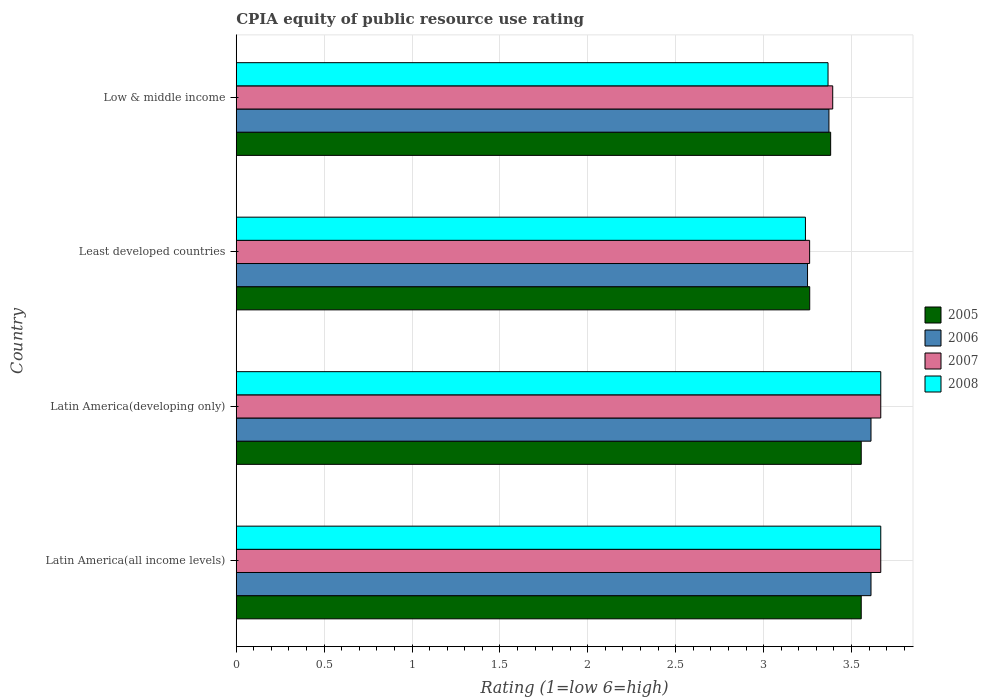How many different coloured bars are there?
Provide a short and direct response. 4. How many groups of bars are there?
Offer a very short reply. 4. Are the number of bars per tick equal to the number of legend labels?
Provide a short and direct response. Yes. How many bars are there on the 4th tick from the bottom?
Make the answer very short. 4. What is the label of the 4th group of bars from the top?
Your response must be concise. Latin America(all income levels). What is the CPIA rating in 2006 in Latin America(developing only)?
Your response must be concise. 3.61. Across all countries, what is the maximum CPIA rating in 2005?
Offer a terse response. 3.56. Across all countries, what is the minimum CPIA rating in 2008?
Your answer should be very brief. 3.24. In which country was the CPIA rating in 2005 maximum?
Make the answer very short. Latin America(all income levels). In which country was the CPIA rating in 2007 minimum?
Give a very brief answer. Least developed countries. What is the total CPIA rating in 2008 in the graph?
Make the answer very short. 13.94. What is the difference between the CPIA rating in 2008 in Latin America(developing only) and that in Least developed countries?
Provide a succinct answer. 0.43. What is the difference between the CPIA rating in 2007 in Latin America(all income levels) and the CPIA rating in 2005 in Least developed countries?
Your answer should be compact. 0.4. What is the average CPIA rating in 2007 per country?
Keep it short and to the point. 3.5. What is the difference between the CPIA rating in 2006 and CPIA rating in 2007 in Latin America(developing only)?
Your answer should be compact. -0.06. In how many countries, is the CPIA rating in 2006 greater than 3.4 ?
Your response must be concise. 2. What is the ratio of the CPIA rating in 2008 in Latin America(all income levels) to that in Low & middle income?
Provide a succinct answer. 1.09. Is the difference between the CPIA rating in 2006 in Latin America(developing only) and Low & middle income greater than the difference between the CPIA rating in 2007 in Latin America(developing only) and Low & middle income?
Make the answer very short. No. What is the difference between the highest and the lowest CPIA rating in 2006?
Ensure brevity in your answer.  0.36. In how many countries, is the CPIA rating in 2006 greater than the average CPIA rating in 2006 taken over all countries?
Make the answer very short. 2. Is it the case that in every country, the sum of the CPIA rating in 2005 and CPIA rating in 2008 is greater than the sum of CPIA rating in 2006 and CPIA rating in 2007?
Offer a very short reply. No. What does the 2nd bar from the top in Latin America(developing only) represents?
Offer a very short reply. 2007. What does the 4th bar from the bottom in Latin America(developing only) represents?
Your answer should be very brief. 2008. Is it the case that in every country, the sum of the CPIA rating in 2005 and CPIA rating in 2007 is greater than the CPIA rating in 2008?
Ensure brevity in your answer.  Yes. What is the difference between two consecutive major ticks on the X-axis?
Your answer should be compact. 0.5. Are the values on the major ticks of X-axis written in scientific E-notation?
Your answer should be very brief. No. Does the graph contain grids?
Ensure brevity in your answer.  Yes. How many legend labels are there?
Your response must be concise. 4. What is the title of the graph?
Your response must be concise. CPIA equity of public resource use rating. What is the label or title of the X-axis?
Make the answer very short. Rating (1=low 6=high). What is the label or title of the Y-axis?
Offer a terse response. Country. What is the Rating (1=low 6=high) of 2005 in Latin America(all income levels)?
Make the answer very short. 3.56. What is the Rating (1=low 6=high) in 2006 in Latin America(all income levels)?
Your response must be concise. 3.61. What is the Rating (1=low 6=high) in 2007 in Latin America(all income levels)?
Provide a succinct answer. 3.67. What is the Rating (1=low 6=high) of 2008 in Latin America(all income levels)?
Your answer should be compact. 3.67. What is the Rating (1=low 6=high) in 2005 in Latin America(developing only)?
Give a very brief answer. 3.56. What is the Rating (1=low 6=high) in 2006 in Latin America(developing only)?
Provide a short and direct response. 3.61. What is the Rating (1=low 6=high) of 2007 in Latin America(developing only)?
Your answer should be compact. 3.67. What is the Rating (1=low 6=high) of 2008 in Latin America(developing only)?
Ensure brevity in your answer.  3.67. What is the Rating (1=low 6=high) in 2005 in Least developed countries?
Offer a very short reply. 3.26. What is the Rating (1=low 6=high) of 2006 in Least developed countries?
Give a very brief answer. 3.25. What is the Rating (1=low 6=high) in 2007 in Least developed countries?
Keep it short and to the point. 3.26. What is the Rating (1=low 6=high) in 2008 in Least developed countries?
Keep it short and to the point. 3.24. What is the Rating (1=low 6=high) of 2005 in Low & middle income?
Your response must be concise. 3.38. What is the Rating (1=low 6=high) of 2006 in Low & middle income?
Provide a succinct answer. 3.37. What is the Rating (1=low 6=high) of 2007 in Low & middle income?
Provide a succinct answer. 3.39. What is the Rating (1=low 6=high) of 2008 in Low & middle income?
Provide a succinct answer. 3.37. Across all countries, what is the maximum Rating (1=low 6=high) in 2005?
Your response must be concise. 3.56. Across all countries, what is the maximum Rating (1=low 6=high) in 2006?
Provide a short and direct response. 3.61. Across all countries, what is the maximum Rating (1=low 6=high) in 2007?
Your answer should be very brief. 3.67. Across all countries, what is the maximum Rating (1=low 6=high) of 2008?
Offer a very short reply. 3.67. Across all countries, what is the minimum Rating (1=low 6=high) in 2005?
Your answer should be compact. 3.26. Across all countries, what is the minimum Rating (1=low 6=high) of 2007?
Ensure brevity in your answer.  3.26. Across all countries, what is the minimum Rating (1=low 6=high) in 2008?
Ensure brevity in your answer.  3.24. What is the total Rating (1=low 6=high) of 2005 in the graph?
Provide a succinct answer. 13.76. What is the total Rating (1=low 6=high) of 2006 in the graph?
Your response must be concise. 13.84. What is the total Rating (1=low 6=high) in 2007 in the graph?
Make the answer very short. 13.99. What is the total Rating (1=low 6=high) of 2008 in the graph?
Offer a terse response. 13.94. What is the difference between the Rating (1=low 6=high) of 2005 in Latin America(all income levels) and that in Latin America(developing only)?
Your answer should be very brief. 0. What is the difference between the Rating (1=low 6=high) of 2006 in Latin America(all income levels) and that in Latin America(developing only)?
Provide a succinct answer. 0. What is the difference between the Rating (1=low 6=high) in 2008 in Latin America(all income levels) and that in Latin America(developing only)?
Offer a terse response. 0. What is the difference between the Rating (1=low 6=high) of 2005 in Latin America(all income levels) and that in Least developed countries?
Make the answer very short. 0.29. What is the difference between the Rating (1=low 6=high) in 2006 in Latin America(all income levels) and that in Least developed countries?
Ensure brevity in your answer.  0.36. What is the difference between the Rating (1=low 6=high) of 2007 in Latin America(all income levels) and that in Least developed countries?
Your response must be concise. 0.4. What is the difference between the Rating (1=low 6=high) of 2008 in Latin America(all income levels) and that in Least developed countries?
Ensure brevity in your answer.  0.43. What is the difference between the Rating (1=low 6=high) in 2005 in Latin America(all income levels) and that in Low & middle income?
Your answer should be compact. 0.17. What is the difference between the Rating (1=low 6=high) of 2006 in Latin America(all income levels) and that in Low & middle income?
Offer a very short reply. 0.24. What is the difference between the Rating (1=low 6=high) in 2007 in Latin America(all income levels) and that in Low & middle income?
Your answer should be compact. 0.27. What is the difference between the Rating (1=low 6=high) of 2008 in Latin America(all income levels) and that in Low & middle income?
Provide a short and direct response. 0.3. What is the difference between the Rating (1=low 6=high) of 2005 in Latin America(developing only) and that in Least developed countries?
Your response must be concise. 0.29. What is the difference between the Rating (1=low 6=high) in 2006 in Latin America(developing only) and that in Least developed countries?
Provide a succinct answer. 0.36. What is the difference between the Rating (1=low 6=high) of 2007 in Latin America(developing only) and that in Least developed countries?
Your answer should be very brief. 0.4. What is the difference between the Rating (1=low 6=high) of 2008 in Latin America(developing only) and that in Least developed countries?
Provide a succinct answer. 0.43. What is the difference between the Rating (1=low 6=high) in 2005 in Latin America(developing only) and that in Low & middle income?
Ensure brevity in your answer.  0.17. What is the difference between the Rating (1=low 6=high) in 2006 in Latin America(developing only) and that in Low & middle income?
Keep it short and to the point. 0.24. What is the difference between the Rating (1=low 6=high) of 2007 in Latin America(developing only) and that in Low & middle income?
Offer a terse response. 0.27. What is the difference between the Rating (1=low 6=high) in 2008 in Latin America(developing only) and that in Low & middle income?
Provide a succinct answer. 0.3. What is the difference between the Rating (1=low 6=high) of 2005 in Least developed countries and that in Low & middle income?
Your answer should be very brief. -0.12. What is the difference between the Rating (1=low 6=high) in 2006 in Least developed countries and that in Low & middle income?
Offer a very short reply. -0.12. What is the difference between the Rating (1=low 6=high) in 2007 in Least developed countries and that in Low & middle income?
Give a very brief answer. -0.13. What is the difference between the Rating (1=low 6=high) of 2008 in Least developed countries and that in Low & middle income?
Keep it short and to the point. -0.13. What is the difference between the Rating (1=low 6=high) in 2005 in Latin America(all income levels) and the Rating (1=low 6=high) in 2006 in Latin America(developing only)?
Keep it short and to the point. -0.06. What is the difference between the Rating (1=low 6=high) of 2005 in Latin America(all income levels) and the Rating (1=low 6=high) of 2007 in Latin America(developing only)?
Offer a terse response. -0.11. What is the difference between the Rating (1=low 6=high) of 2005 in Latin America(all income levels) and the Rating (1=low 6=high) of 2008 in Latin America(developing only)?
Your answer should be very brief. -0.11. What is the difference between the Rating (1=low 6=high) of 2006 in Latin America(all income levels) and the Rating (1=low 6=high) of 2007 in Latin America(developing only)?
Offer a terse response. -0.06. What is the difference between the Rating (1=low 6=high) of 2006 in Latin America(all income levels) and the Rating (1=low 6=high) of 2008 in Latin America(developing only)?
Your answer should be compact. -0.06. What is the difference between the Rating (1=low 6=high) of 2007 in Latin America(all income levels) and the Rating (1=low 6=high) of 2008 in Latin America(developing only)?
Provide a short and direct response. 0. What is the difference between the Rating (1=low 6=high) of 2005 in Latin America(all income levels) and the Rating (1=low 6=high) of 2006 in Least developed countries?
Your answer should be very brief. 0.31. What is the difference between the Rating (1=low 6=high) of 2005 in Latin America(all income levels) and the Rating (1=low 6=high) of 2007 in Least developed countries?
Offer a very short reply. 0.29. What is the difference between the Rating (1=low 6=high) in 2005 in Latin America(all income levels) and the Rating (1=low 6=high) in 2008 in Least developed countries?
Keep it short and to the point. 0.32. What is the difference between the Rating (1=low 6=high) in 2006 in Latin America(all income levels) and the Rating (1=low 6=high) in 2007 in Least developed countries?
Provide a succinct answer. 0.35. What is the difference between the Rating (1=low 6=high) of 2006 in Latin America(all income levels) and the Rating (1=low 6=high) of 2008 in Least developed countries?
Your answer should be very brief. 0.37. What is the difference between the Rating (1=low 6=high) in 2007 in Latin America(all income levels) and the Rating (1=low 6=high) in 2008 in Least developed countries?
Ensure brevity in your answer.  0.43. What is the difference between the Rating (1=low 6=high) of 2005 in Latin America(all income levels) and the Rating (1=low 6=high) of 2006 in Low & middle income?
Provide a succinct answer. 0.18. What is the difference between the Rating (1=low 6=high) of 2005 in Latin America(all income levels) and the Rating (1=low 6=high) of 2007 in Low & middle income?
Offer a very short reply. 0.16. What is the difference between the Rating (1=low 6=high) of 2005 in Latin America(all income levels) and the Rating (1=low 6=high) of 2008 in Low & middle income?
Keep it short and to the point. 0.19. What is the difference between the Rating (1=low 6=high) of 2006 in Latin America(all income levels) and the Rating (1=low 6=high) of 2007 in Low & middle income?
Ensure brevity in your answer.  0.22. What is the difference between the Rating (1=low 6=high) of 2006 in Latin America(all income levels) and the Rating (1=low 6=high) of 2008 in Low & middle income?
Offer a terse response. 0.24. What is the difference between the Rating (1=low 6=high) in 2005 in Latin America(developing only) and the Rating (1=low 6=high) in 2006 in Least developed countries?
Keep it short and to the point. 0.31. What is the difference between the Rating (1=low 6=high) of 2005 in Latin America(developing only) and the Rating (1=low 6=high) of 2007 in Least developed countries?
Your answer should be very brief. 0.29. What is the difference between the Rating (1=low 6=high) of 2005 in Latin America(developing only) and the Rating (1=low 6=high) of 2008 in Least developed countries?
Make the answer very short. 0.32. What is the difference between the Rating (1=low 6=high) of 2006 in Latin America(developing only) and the Rating (1=low 6=high) of 2007 in Least developed countries?
Offer a very short reply. 0.35. What is the difference between the Rating (1=low 6=high) in 2006 in Latin America(developing only) and the Rating (1=low 6=high) in 2008 in Least developed countries?
Keep it short and to the point. 0.37. What is the difference between the Rating (1=low 6=high) in 2007 in Latin America(developing only) and the Rating (1=low 6=high) in 2008 in Least developed countries?
Your response must be concise. 0.43. What is the difference between the Rating (1=low 6=high) of 2005 in Latin America(developing only) and the Rating (1=low 6=high) of 2006 in Low & middle income?
Provide a short and direct response. 0.18. What is the difference between the Rating (1=low 6=high) of 2005 in Latin America(developing only) and the Rating (1=low 6=high) of 2007 in Low & middle income?
Provide a short and direct response. 0.16. What is the difference between the Rating (1=low 6=high) of 2005 in Latin America(developing only) and the Rating (1=low 6=high) of 2008 in Low & middle income?
Make the answer very short. 0.19. What is the difference between the Rating (1=low 6=high) in 2006 in Latin America(developing only) and the Rating (1=low 6=high) in 2007 in Low & middle income?
Your response must be concise. 0.22. What is the difference between the Rating (1=low 6=high) of 2006 in Latin America(developing only) and the Rating (1=low 6=high) of 2008 in Low & middle income?
Make the answer very short. 0.24. What is the difference between the Rating (1=low 6=high) in 2007 in Latin America(developing only) and the Rating (1=low 6=high) in 2008 in Low & middle income?
Keep it short and to the point. 0.3. What is the difference between the Rating (1=low 6=high) of 2005 in Least developed countries and the Rating (1=low 6=high) of 2006 in Low & middle income?
Your answer should be compact. -0.11. What is the difference between the Rating (1=low 6=high) of 2005 in Least developed countries and the Rating (1=low 6=high) of 2007 in Low & middle income?
Provide a short and direct response. -0.13. What is the difference between the Rating (1=low 6=high) of 2005 in Least developed countries and the Rating (1=low 6=high) of 2008 in Low & middle income?
Ensure brevity in your answer.  -0.1. What is the difference between the Rating (1=low 6=high) of 2006 in Least developed countries and the Rating (1=low 6=high) of 2007 in Low & middle income?
Offer a terse response. -0.14. What is the difference between the Rating (1=low 6=high) in 2006 in Least developed countries and the Rating (1=low 6=high) in 2008 in Low & middle income?
Your response must be concise. -0.12. What is the difference between the Rating (1=low 6=high) in 2007 in Least developed countries and the Rating (1=low 6=high) in 2008 in Low & middle income?
Your answer should be very brief. -0.1. What is the average Rating (1=low 6=high) of 2005 per country?
Offer a terse response. 3.44. What is the average Rating (1=low 6=high) in 2006 per country?
Make the answer very short. 3.46. What is the average Rating (1=low 6=high) in 2007 per country?
Keep it short and to the point. 3.5. What is the average Rating (1=low 6=high) in 2008 per country?
Keep it short and to the point. 3.48. What is the difference between the Rating (1=low 6=high) of 2005 and Rating (1=low 6=high) of 2006 in Latin America(all income levels)?
Provide a succinct answer. -0.06. What is the difference between the Rating (1=low 6=high) in 2005 and Rating (1=low 6=high) in 2007 in Latin America(all income levels)?
Offer a very short reply. -0.11. What is the difference between the Rating (1=low 6=high) in 2005 and Rating (1=low 6=high) in 2008 in Latin America(all income levels)?
Provide a short and direct response. -0.11. What is the difference between the Rating (1=low 6=high) of 2006 and Rating (1=low 6=high) of 2007 in Latin America(all income levels)?
Ensure brevity in your answer.  -0.06. What is the difference between the Rating (1=low 6=high) of 2006 and Rating (1=low 6=high) of 2008 in Latin America(all income levels)?
Provide a short and direct response. -0.06. What is the difference between the Rating (1=low 6=high) in 2005 and Rating (1=low 6=high) in 2006 in Latin America(developing only)?
Keep it short and to the point. -0.06. What is the difference between the Rating (1=low 6=high) of 2005 and Rating (1=low 6=high) of 2007 in Latin America(developing only)?
Offer a terse response. -0.11. What is the difference between the Rating (1=low 6=high) of 2005 and Rating (1=low 6=high) of 2008 in Latin America(developing only)?
Provide a short and direct response. -0.11. What is the difference between the Rating (1=low 6=high) in 2006 and Rating (1=low 6=high) in 2007 in Latin America(developing only)?
Give a very brief answer. -0.06. What is the difference between the Rating (1=low 6=high) of 2006 and Rating (1=low 6=high) of 2008 in Latin America(developing only)?
Offer a very short reply. -0.06. What is the difference between the Rating (1=low 6=high) of 2007 and Rating (1=low 6=high) of 2008 in Latin America(developing only)?
Provide a short and direct response. 0. What is the difference between the Rating (1=low 6=high) in 2005 and Rating (1=low 6=high) in 2006 in Least developed countries?
Your answer should be very brief. 0.01. What is the difference between the Rating (1=low 6=high) of 2005 and Rating (1=low 6=high) of 2007 in Least developed countries?
Offer a very short reply. 0. What is the difference between the Rating (1=low 6=high) in 2005 and Rating (1=low 6=high) in 2008 in Least developed countries?
Give a very brief answer. 0.02. What is the difference between the Rating (1=low 6=high) in 2006 and Rating (1=low 6=high) in 2007 in Least developed countries?
Your answer should be very brief. -0.01. What is the difference between the Rating (1=low 6=high) of 2006 and Rating (1=low 6=high) of 2008 in Least developed countries?
Give a very brief answer. 0.01. What is the difference between the Rating (1=low 6=high) of 2007 and Rating (1=low 6=high) of 2008 in Least developed countries?
Your answer should be compact. 0.02. What is the difference between the Rating (1=low 6=high) of 2005 and Rating (1=low 6=high) of 2006 in Low & middle income?
Ensure brevity in your answer.  0.01. What is the difference between the Rating (1=low 6=high) of 2005 and Rating (1=low 6=high) of 2007 in Low & middle income?
Your answer should be compact. -0.01. What is the difference between the Rating (1=low 6=high) of 2005 and Rating (1=low 6=high) of 2008 in Low & middle income?
Offer a very short reply. 0.01. What is the difference between the Rating (1=low 6=high) in 2006 and Rating (1=low 6=high) in 2007 in Low & middle income?
Keep it short and to the point. -0.02. What is the difference between the Rating (1=low 6=high) of 2006 and Rating (1=low 6=high) of 2008 in Low & middle income?
Offer a terse response. 0.01. What is the difference between the Rating (1=low 6=high) in 2007 and Rating (1=low 6=high) in 2008 in Low & middle income?
Your response must be concise. 0.03. What is the ratio of the Rating (1=low 6=high) in 2005 in Latin America(all income levels) to that in Latin America(developing only)?
Provide a succinct answer. 1. What is the ratio of the Rating (1=low 6=high) of 2007 in Latin America(all income levels) to that in Latin America(developing only)?
Your answer should be compact. 1. What is the ratio of the Rating (1=low 6=high) in 2008 in Latin America(all income levels) to that in Latin America(developing only)?
Your answer should be compact. 1. What is the ratio of the Rating (1=low 6=high) of 2005 in Latin America(all income levels) to that in Least developed countries?
Offer a terse response. 1.09. What is the ratio of the Rating (1=low 6=high) of 2007 in Latin America(all income levels) to that in Least developed countries?
Your answer should be very brief. 1.12. What is the ratio of the Rating (1=low 6=high) in 2008 in Latin America(all income levels) to that in Least developed countries?
Offer a very short reply. 1.13. What is the ratio of the Rating (1=low 6=high) of 2005 in Latin America(all income levels) to that in Low & middle income?
Offer a terse response. 1.05. What is the ratio of the Rating (1=low 6=high) in 2006 in Latin America(all income levels) to that in Low & middle income?
Keep it short and to the point. 1.07. What is the ratio of the Rating (1=low 6=high) in 2007 in Latin America(all income levels) to that in Low & middle income?
Keep it short and to the point. 1.08. What is the ratio of the Rating (1=low 6=high) in 2008 in Latin America(all income levels) to that in Low & middle income?
Keep it short and to the point. 1.09. What is the ratio of the Rating (1=low 6=high) in 2005 in Latin America(developing only) to that in Least developed countries?
Ensure brevity in your answer.  1.09. What is the ratio of the Rating (1=low 6=high) of 2006 in Latin America(developing only) to that in Least developed countries?
Give a very brief answer. 1.11. What is the ratio of the Rating (1=low 6=high) of 2007 in Latin America(developing only) to that in Least developed countries?
Your answer should be compact. 1.12. What is the ratio of the Rating (1=low 6=high) in 2008 in Latin America(developing only) to that in Least developed countries?
Provide a succinct answer. 1.13. What is the ratio of the Rating (1=low 6=high) of 2005 in Latin America(developing only) to that in Low & middle income?
Provide a short and direct response. 1.05. What is the ratio of the Rating (1=low 6=high) in 2006 in Latin America(developing only) to that in Low & middle income?
Your answer should be compact. 1.07. What is the ratio of the Rating (1=low 6=high) of 2007 in Latin America(developing only) to that in Low & middle income?
Offer a terse response. 1.08. What is the ratio of the Rating (1=low 6=high) of 2008 in Latin America(developing only) to that in Low & middle income?
Give a very brief answer. 1.09. What is the ratio of the Rating (1=low 6=high) in 2005 in Least developed countries to that in Low & middle income?
Provide a succinct answer. 0.96. What is the ratio of the Rating (1=low 6=high) in 2006 in Least developed countries to that in Low & middle income?
Provide a short and direct response. 0.96. What is the ratio of the Rating (1=low 6=high) in 2007 in Least developed countries to that in Low & middle income?
Give a very brief answer. 0.96. What is the ratio of the Rating (1=low 6=high) of 2008 in Least developed countries to that in Low & middle income?
Provide a short and direct response. 0.96. What is the difference between the highest and the second highest Rating (1=low 6=high) in 2005?
Provide a short and direct response. 0. What is the difference between the highest and the second highest Rating (1=low 6=high) of 2008?
Give a very brief answer. 0. What is the difference between the highest and the lowest Rating (1=low 6=high) of 2005?
Your answer should be very brief. 0.29. What is the difference between the highest and the lowest Rating (1=low 6=high) in 2006?
Give a very brief answer. 0.36. What is the difference between the highest and the lowest Rating (1=low 6=high) of 2007?
Your answer should be compact. 0.4. What is the difference between the highest and the lowest Rating (1=low 6=high) of 2008?
Your response must be concise. 0.43. 